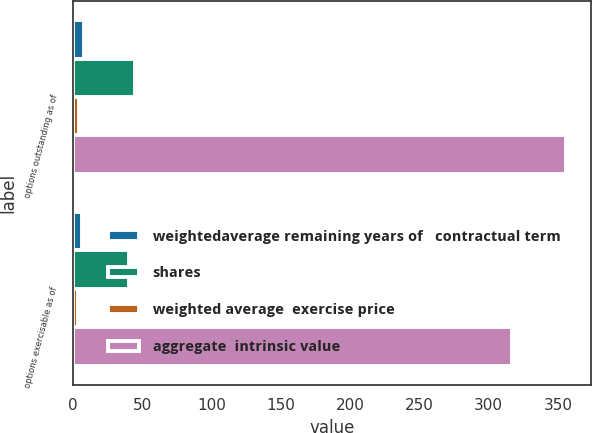<chart> <loc_0><loc_0><loc_500><loc_500><stacked_bar_chart><ecel><fcel>options outstanding as of<fcel>options exercisable as of<nl><fcel>weightedaverage remaining years of   contractual term<fcel>8.1<fcel>6.5<nl><fcel>shares<fcel>45.18<fcel>40.28<nl><fcel>weighted average  exercise price<fcel>4.8<fcel>3.8<nl><fcel>aggregate  intrinsic value<fcel>356<fcel>317<nl></chart> 